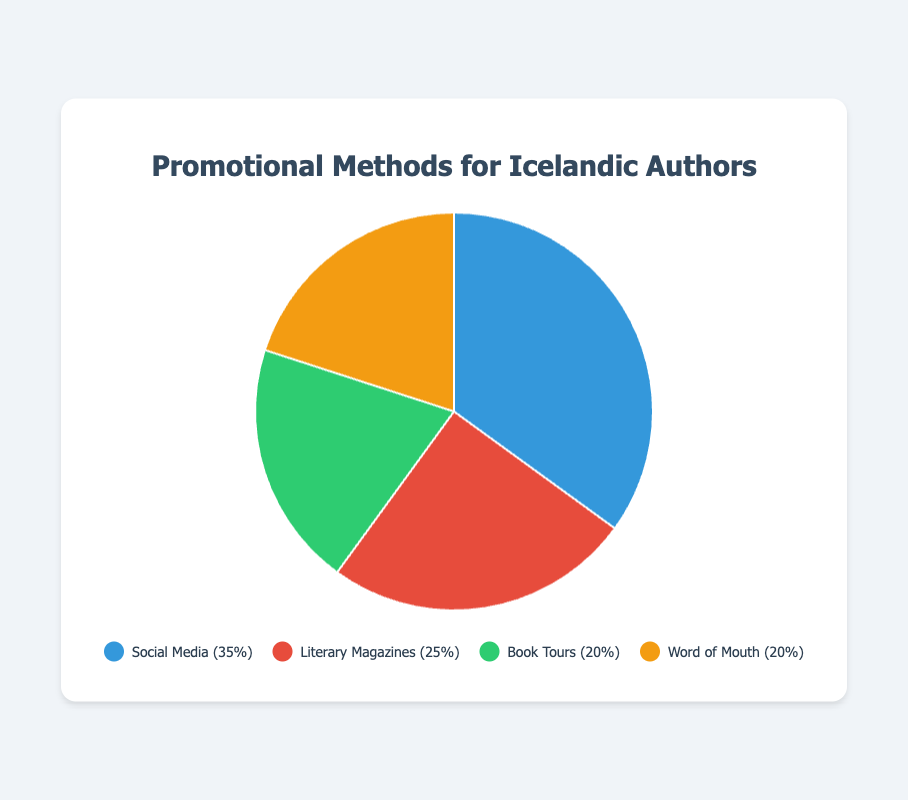What is the most popular promotional method? The largest section of the pie chart represents the most popular method. The "Social Media" section is the largest.
Answer: Social Media What percentage of promotional methods are not based on Social Media? Subtract the share of Social Media from 100%. 100% - 35% = 65%
Answer: 65% How does the share of Book Tours compare to the share of Word of Mouth? Both Book Tours and Word of Mouth have equal shares.
Answer: Equal Which promotional method has the smallest share? The smallest sections of the pie chart represent the smallest shares. Both Book Tours and Word of Mouth have the smallest shares at 20% each.
Answer: Book Tours and Word of Mouth What is the total share of Literary Magazines and Word of Mouth combined? Add the shares of Literary Magazines and Word of Mouth. 25% + 20% = 45%
Answer: 45% What color represents Literary Magazines in the chart? Observing the pie chart, Literary Magazines is represented by the section in red.
Answer: Red Is the share of Social Media greater than the combined share of Book Tours and Word of Mouth? Compare the share of Social Media (35%) to the combined share of Book Tours and Word of Mouth (20% + 20% = 40%). 35% is less than 40%.
Answer: No Which segments in the pie chart are represented by the same percentage? Both Book Tours and Word of Mouth have a share of 20%.
Answer: Book Tours and Word of Mouth What is the difference in share between Social Media and Literary Magazines? Subtract the share of Literary Magazines from the share of Social Media. 35% - 25% = 10%
Answer: 10% Based on color, which promotional method is represented by green in the pie chart? Observing the pie chart, Book Tours is represented by the green section.
Answer: Book Tours 